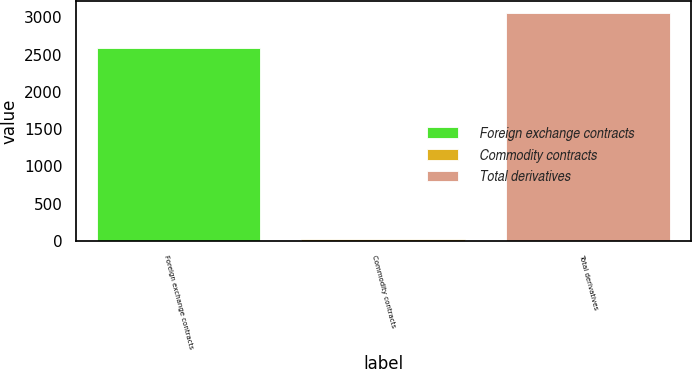Convert chart to OTSL. <chart><loc_0><loc_0><loc_500><loc_500><bar_chart><fcel>Foreign exchange contracts<fcel>Commodity contracts<fcel>Total derivatives<nl><fcel>2586<fcel>31<fcel>3064<nl></chart> 